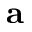<formula> <loc_0><loc_0><loc_500><loc_500>a</formula> 